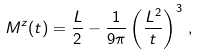Convert formula to latex. <formula><loc_0><loc_0><loc_500><loc_500>M ^ { z } ( t ) = \frac { L } { 2 } - \frac { 1 } { 9 \pi } \left ( \frac { L ^ { 2 } } { t } \right ) ^ { 3 } \, ,</formula> 